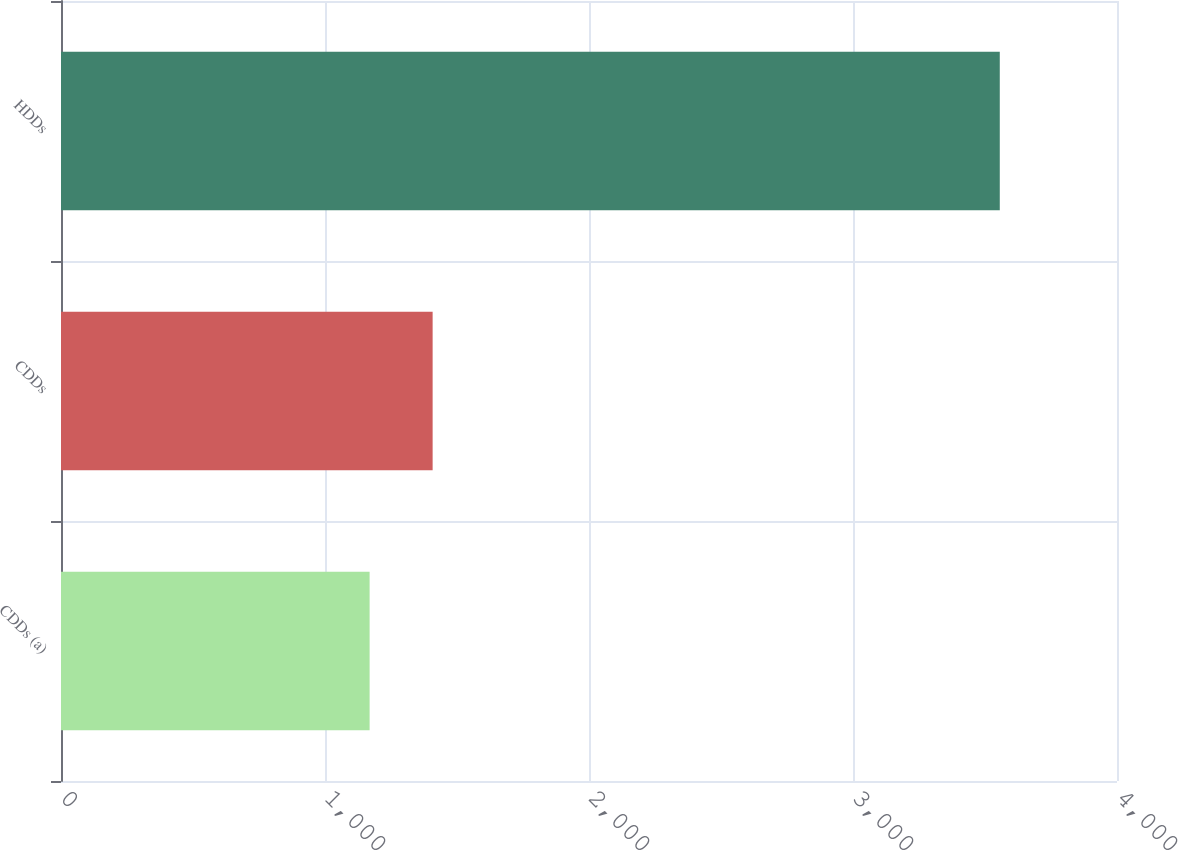Convert chart. <chart><loc_0><loc_0><loc_500><loc_500><bar_chart><fcel>CDDs (a)<fcel>CDDs<fcel>HDDs<nl><fcel>1169<fcel>1407.7<fcel>3556<nl></chart> 